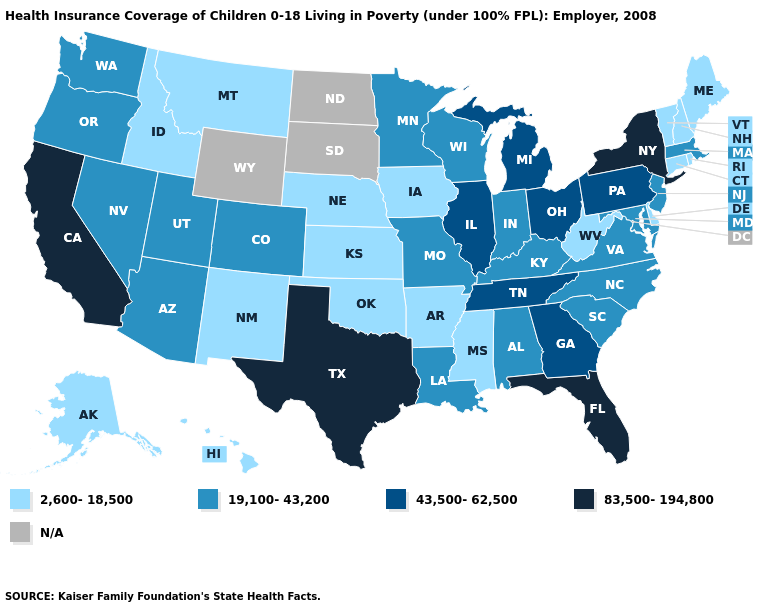How many symbols are there in the legend?
Quick response, please. 5. Which states hav the highest value in the MidWest?
Write a very short answer. Illinois, Michigan, Ohio. Name the states that have a value in the range 19,100-43,200?
Concise answer only. Alabama, Arizona, Colorado, Indiana, Kentucky, Louisiana, Maryland, Massachusetts, Minnesota, Missouri, Nevada, New Jersey, North Carolina, Oregon, South Carolina, Utah, Virginia, Washington, Wisconsin. Among the states that border New York , does New Jersey have the lowest value?
Give a very brief answer. No. Name the states that have a value in the range N/A?
Keep it brief. North Dakota, South Dakota, Wyoming. Among the states that border Connecticut , does Massachusetts have the highest value?
Write a very short answer. No. Name the states that have a value in the range 19,100-43,200?
Quick response, please. Alabama, Arizona, Colorado, Indiana, Kentucky, Louisiana, Maryland, Massachusetts, Minnesota, Missouri, Nevada, New Jersey, North Carolina, Oregon, South Carolina, Utah, Virginia, Washington, Wisconsin. Among the states that border New Jersey , does Delaware have the lowest value?
Quick response, please. Yes. Among the states that border New Hampshire , does Massachusetts have the highest value?
Give a very brief answer. Yes. What is the value of Idaho?
Short answer required. 2,600-18,500. Does Texas have the lowest value in the South?
Concise answer only. No. Name the states that have a value in the range 43,500-62,500?
Short answer required. Georgia, Illinois, Michigan, Ohio, Pennsylvania, Tennessee. Which states have the highest value in the USA?
Quick response, please. California, Florida, New York, Texas. Is the legend a continuous bar?
Quick response, please. No. 